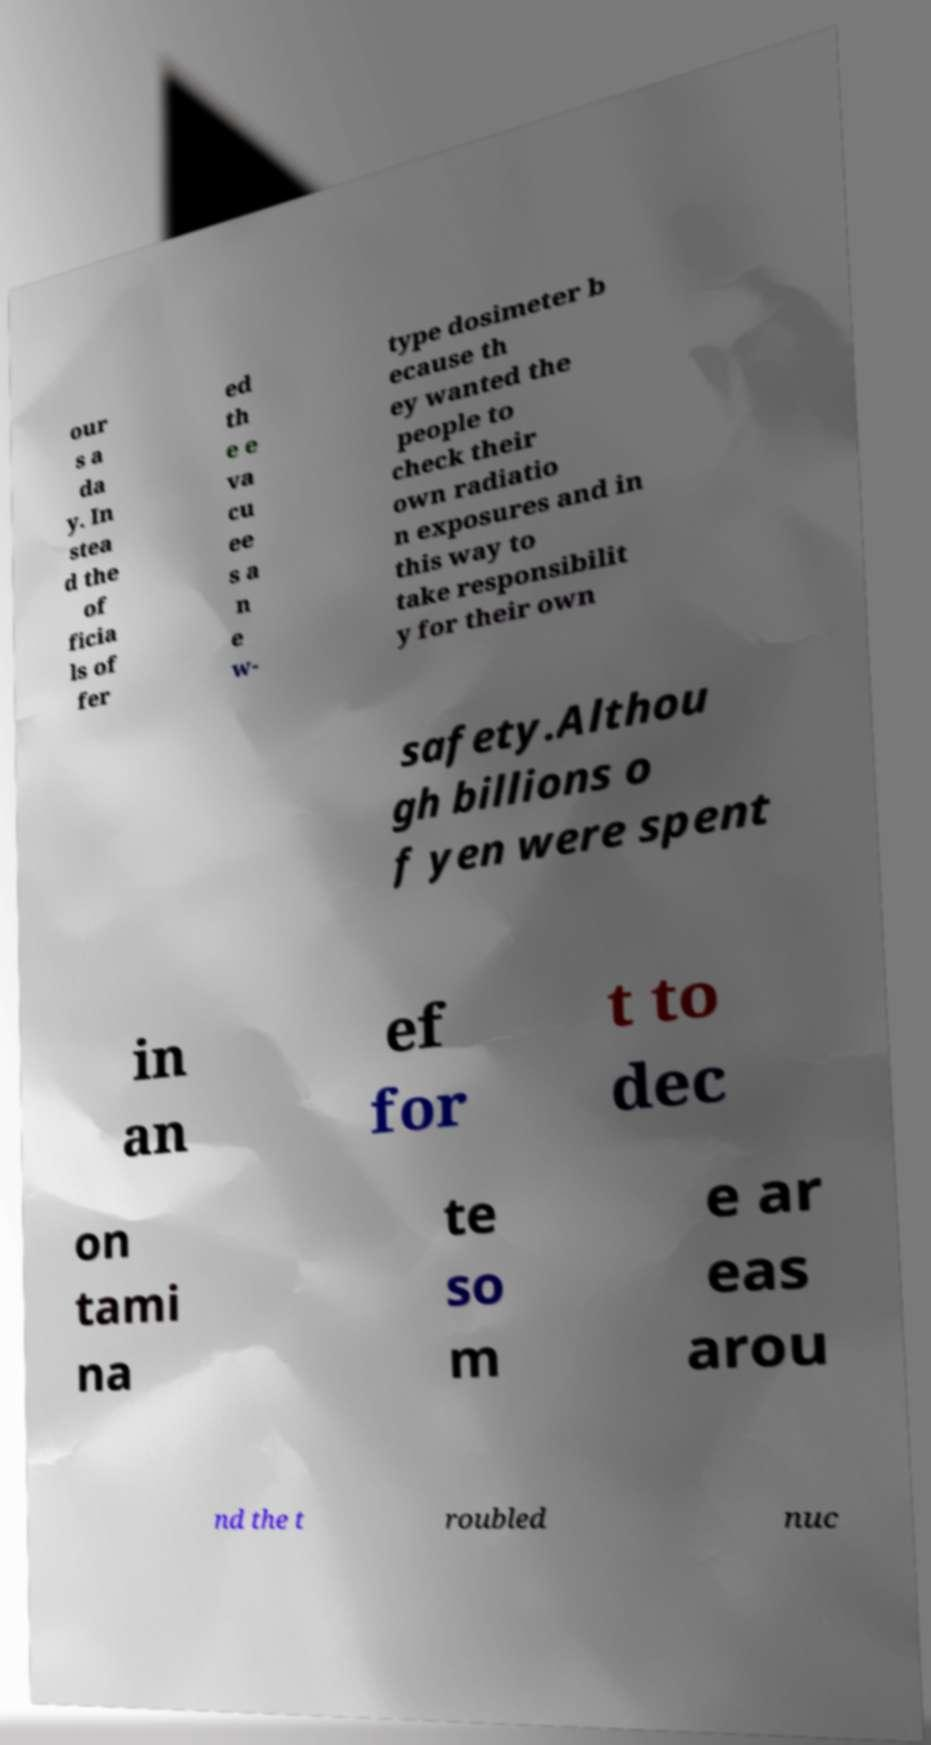Can you accurately transcribe the text from the provided image for me? our s a da y. In stea d the of ficia ls of fer ed th e e va cu ee s a n e w- type dosimeter b ecause th ey wanted the people to check their own radiatio n exposures and in this way to take responsibilit y for their own safety.Althou gh billions o f yen were spent in an ef for t to dec on tami na te so m e ar eas arou nd the t roubled nuc 